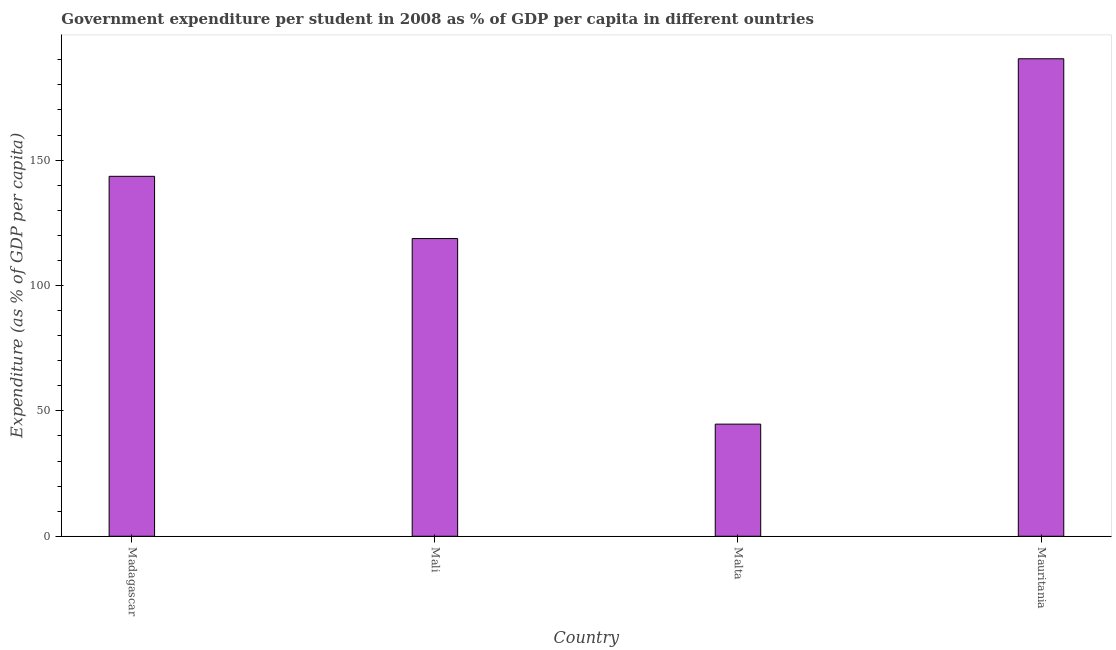What is the title of the graph?
Keep it short and to the point. Government expenditure per student in 2008 as % of GDP per capita in different ountries. What is the label or title of the X-axis?
Keep it short and to the point. Country. What is the label or title of the Y-axis?
Provide a succinct answer. Expenditure (as % of GDP per capita). What is the government expenditure per student in Mali?
Give a very brief answer. 118.71. Across all countries, what is the maximum government expenditure per student?
Make the answer very short. 190.41. Across all countries, what is the minimum government expenditure per student?
Your response must be concise. 44.71. In which country was the government expenditure per student maximum?
Provide a succinct answer. Mauritania. In which country was the government expenditure per student minimum?
Provide a short and direct response. Malta. What is the sum of the government expenditure per student?
Offer a very short reply. 497.37. What is the difference between the government expenditure per student in Malta and Mauritania?
Give a very brief answer. -145.71. What is the average government expenditure per student per country?
Give a very brief answer. 124.34. What is the median government expenditure per student?
Ensure brevity in your answer.  131.12. What is the ratio of the government expenditure per student in Malta to that in Mauritania?
Provide a short and direct response. 0.23. Is the government expenditure per student in Madagascar less than that in Malta?
Ensure brevity in your answer.  No. Is the difference between the government expenditure per student in Madagascar and Mali greater than the difference between any two countries?
Your response must be concise. No. What is the difference between the highest and the second highest government expenditure per student?
Keep it short and to the point. 46.88. What is the difference between the highest and the lowest government expenditure per student?
Ensure brevity in your answer.  145.71. What is the difference between two consecutive major ticks on the Y-axis?
Your answer should be very brief. 50. Are the values on the major ticks of Y-axis written in scientific E-notation?
Your answer should be very brief. No. What is the Expenditure (as % of GDP per capita) of Madagascar?
Your answer should be very brief. 143.53. What is the Expenditure (as % of GDP per capita) of Mali?
Offer a terse response. 118.71. What is the Expenditure (as % of GDP per capita) in Malta?
Offer a terse response. 44.71. What is the Expenditure (as % of GDP per capita) of Mauritania?
Give a very brief answer. 190.41. What is the difference between the Expenditure (as % of GDP per capita) in Madagascar and Mali?
Keep it short and to the point. 24.82. What is the difference between the Expenditure (as % of GDP per capita) in Madagascar and Malta?
Ensure brevity in your answer.  98.83. What is the difference between the Expenditure (as % of GDP per capita) in Madagascar and Mauritania?
Make the answer very short. -46.88. What is the difference between the Expenditure (as % of GDP per capita) in Mali and Malta?
Provide a short and direct response. 74. What is the difference between the Expenditure (as % of GDP per capita) in Mali and Mauritania?
Your answer should be compact. -71.7. What is the difference between the Expenditure (as % of GDP per capita) in Malta and Mauritania?
Make the answer very short. -145.71. What is the ratio of the Expenditure (as % of GDP per capita) in Madagascar to that in Mali?
Give a very brief answer. 1.21. What is the ratio of the Expenditure (as % of GDP per capita) in Madagascar to that in Malta?
Your answer should be compact. 3.21. What is the ratio of the Expenditure (as % of GDP per capita) in Madagascar to that in Mauritania?
Give a very brief answer. 0.75. What is the ratio of the Expenditure (as % of GDP per capita) in Mali to that in Malta?
Ensure brevity in your answer.  2.65. What is the ratio of the Expenditure (as % of GDP per capita) in Mali to that in Mauritania?
Your answer should be very brief. 0.62. What is the ratio of the Expenditure (as % of GDP per capita) in Malta to that in Mauritania?
Make the answer very short. 0.23. 